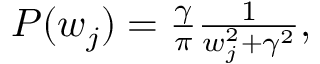<formula> <loc_0><loc_0><loc_500><loc_500>\begin{array} { r } { P ( w _ { j } ) = \frac { \gamma } { \pi } \frac { 1 } { w _ { j } ^ { 2 } + \gamma ^ { 2 } } , } \end{array}</formula> 